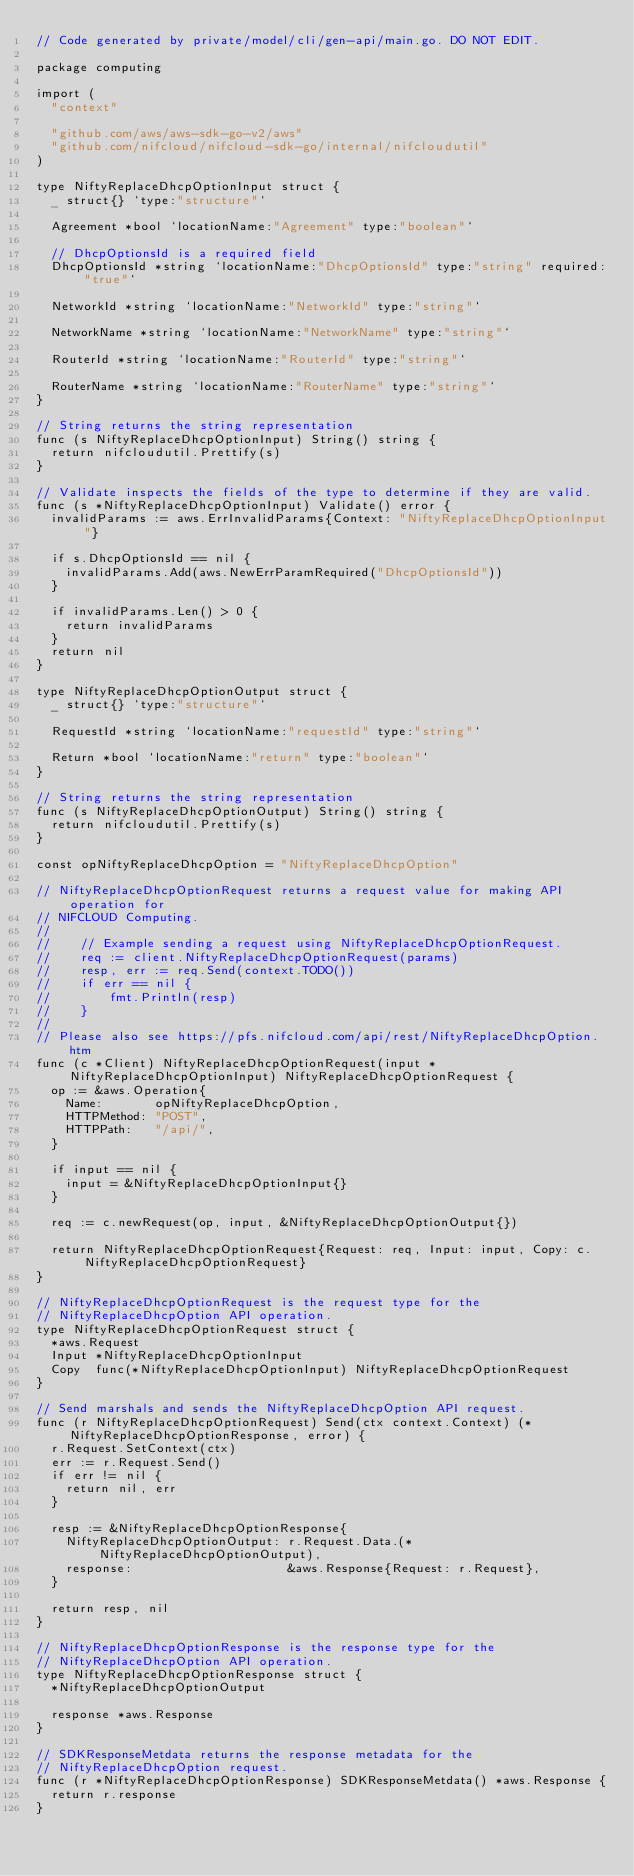<code> <loc_0><loc_0><loc_500><loc_500><_Go_>// Code generated by private/model/cli/gen-api/main.go. DO NOT EDIT.

package computing

import (
	"context"

	"github.com/aws/aws-sdk-go-v2/aws"
	"github.com/nifcloud/nifcloud-sdk-go/internal/nifcloudutil"
)

type NiftyReplaceDhcpOptionInput struct {
	_ struct{} `type:"structure"`

	Agreement *bool `locationName:"Agreement" type:"boolean"`

	// DhcpOptionsId is a required field
	DhcpOptionsId *string `locationName:"DhcpOptionsId" type:"string" required:"true"`

	NetworkId *string `locationName:"NetworkId" type:"string"`

	NetworkName *string `locationName:"NetworkName" type:"string"`

	RouterId *string `locationName:"RouterId" type:"string"`

	RouterName *string `locationName:"RouterName" type:"string"`
}

// String returns the string representation
func (s NiftyReplaceDhcpOptionInput) String() string {
	return nifcloudutil.Prettify(s)
}

// Validate inspects the fields of the type to determine if they are valid.
func (s *NiftyReplaceDhcpOptionInput) Validate() error {
	invalidParams := aws.ErrInvalidParams{Context: "NiftyReplaceDhcpOptionInput"}

	if s.DhcpOptionsId == nil {
		invalidParams.Add(aws.NewErrParamRequired("DhcpOptionsId"))
	}

	if invalidParams.Len() > 0 {
		return invalidParams
	}
	return nil
}

type NiftyReplaceDhcpOptionOutput struct {
	_ struct{} `type:"structure"`

	RequestId *string `locationName:"requestId" type:"string"`

	Return *bool `locationName:"return" type:"boolean"`
}

// String returns the string representation
func (s NiftyReplaceDhcpOptionOutput) String() string {
	return nifcloudutil.Prettify(s)
}

const opNiftyReplaceDhcpOption = "NiftyReplaceDhcpOption"

// NiftyReplaceDhcpOptionRequest returns a request value for making API operation for
// NIFCLOUD Computing.
//
//    // Example sending a request using NiftyReplaceDhcpOptionRequest.
//    req := client.NiftyReplaceDhcpOptionRequest(params)
//    resp, err := req.Send(context.TODO())
//    if err == nil {
//        fmt.Println(resp)
//    }
//
// Please also see https://pfs.nifcloud.com/api/rest/NiftyReplaceDhcpOption.htm
func (c *Client) NiftyReplaceDhcpOptionRequest(input *NiftyReplaceDhcpOptionInput) NiftyReplaceDhcpOptionRequest {
	op := &aws.Operation{
		Name:       opNiftyReplaceDhcpOption,
		HTTPMethod: "POST",
		HTTPPath:   "/api/",
	}

	if input == nil {
		input = &NiftyReplaceDhcpOptionInput{}
	}

	req := c.newRequest(op, input, &NiftyReplaceDhcpOptionOutput{})

	return NiftyReplaceDhcpOptionRequest{Request: req, Input: input, Copy: c.NiftyReplaceDhcpOptionRequest}
}

// NiftyReplaceDhcpOptionRequest is the request type for the
// NiftyReplaceDhcpOption API operation.
type NiftyReplaceDhcpOptionRequest struct {
	*aws.Request
	Input *NiftyReplaceDhcpOptionInput
	Copy  func(*NiftyReplaceDhcpOptionInput) NiftyReplaceDhcpOptionRequest
}

// Send marshals and sends the NiftyReplaceDhcpOption API request.
func (r NiftyReplaceDhcpOptionRequest) Send(ctx context.Context) (*NiftyReplaceDhcpOptionResponse, error) {
	r.Request.SetContext(ctx)
	err := r.Request.Send()
	if err != nil {
		return nil, err
	}

	resp := &NiftyReplaceDhcpOptionResponse{
		NiftyReplaceDhcpOptionOutput: r.Request.Data.(*NiftyReplaceDhcpOptionOutput),
		response:                     &aws.Response{Request: r.Request},
	}

	return resp, nil
}

// NiftyReplaceDhcpOptionResponse is the response type for the
// NiftyReplaceDhcpOption API operation.
type NiftyReplaceDhcpOptionResponse struct {
	*NiftyReplaceDhcpOptionOutput

	response *aws.Response
}

// SDKResponseMetdata returns the response metadata for the
// NiftyReplaceDhcpOption request.
func (r *NiftyReplaceDhcpOptionResponse) SDKResponseMetdata() *aws.Response {
	return r.response
}
</code> 